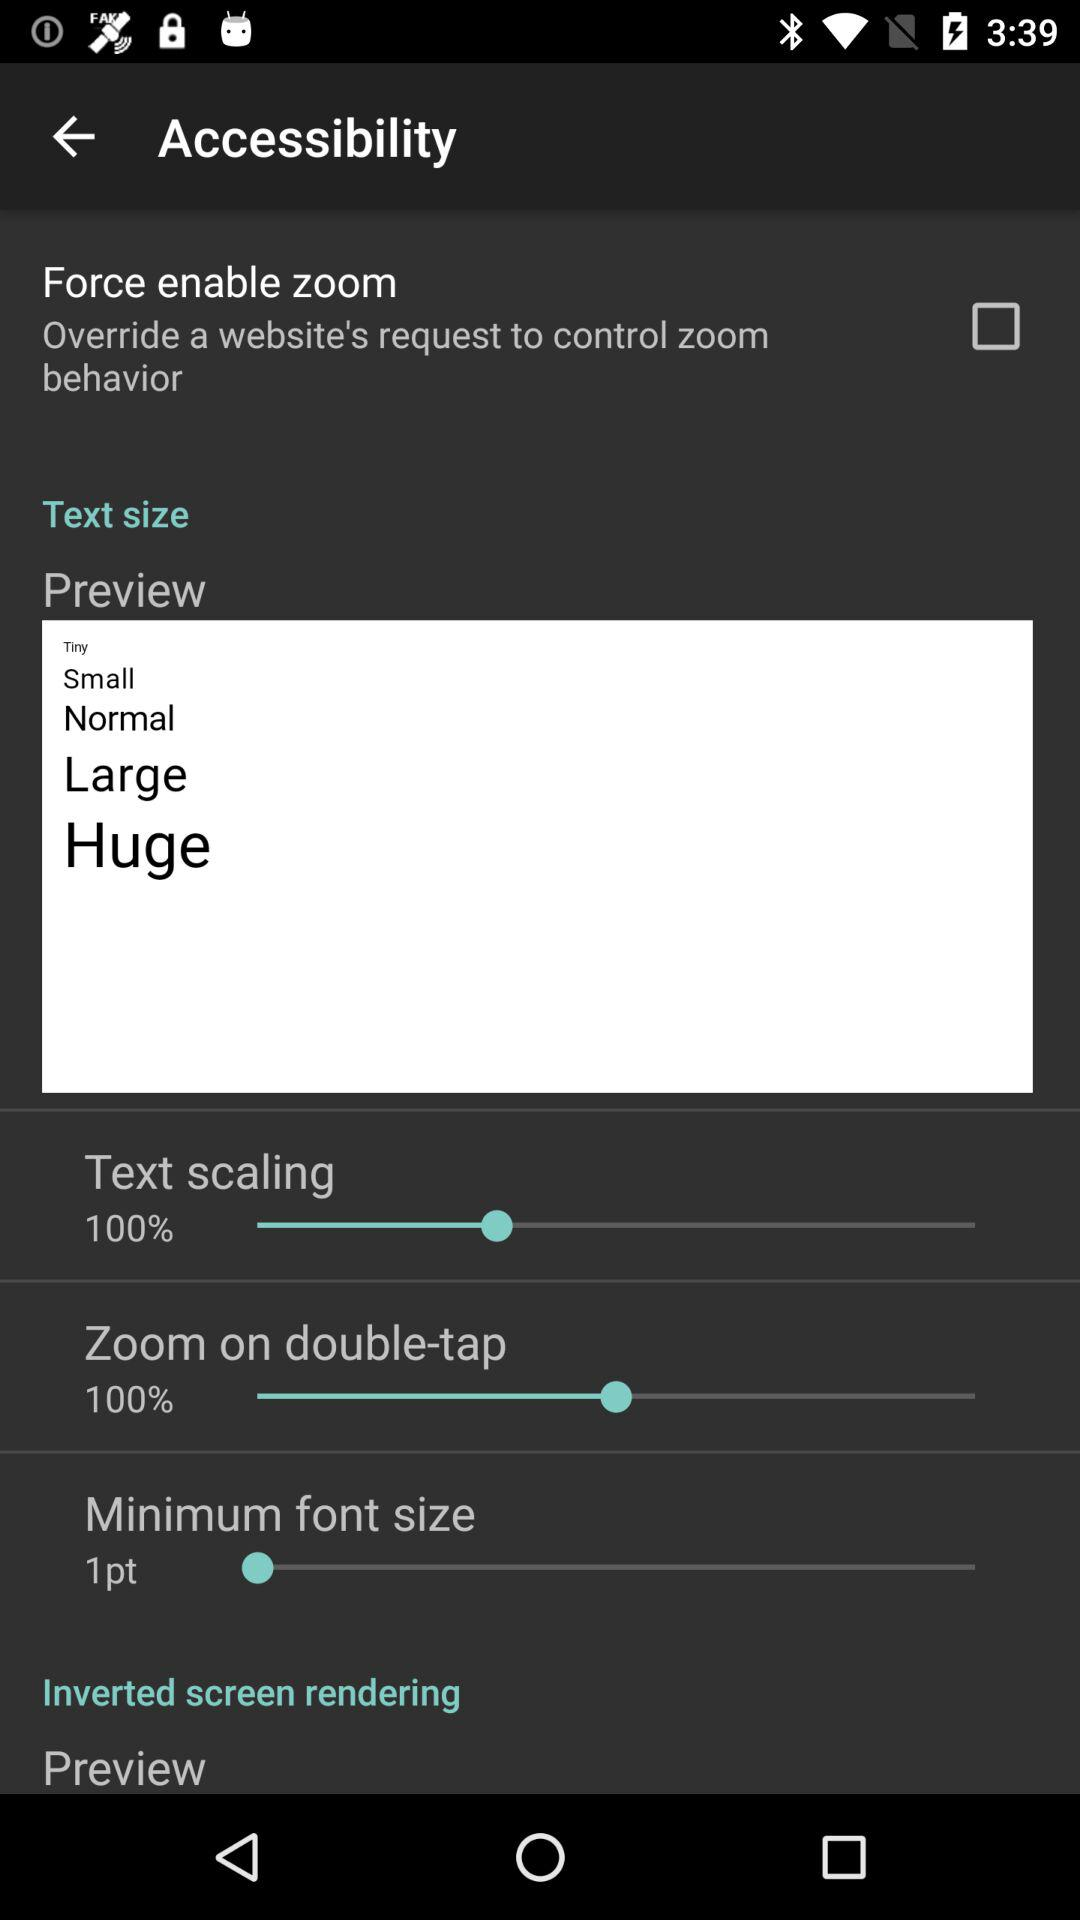What is the text scaling percentage? The percentage is 100. 